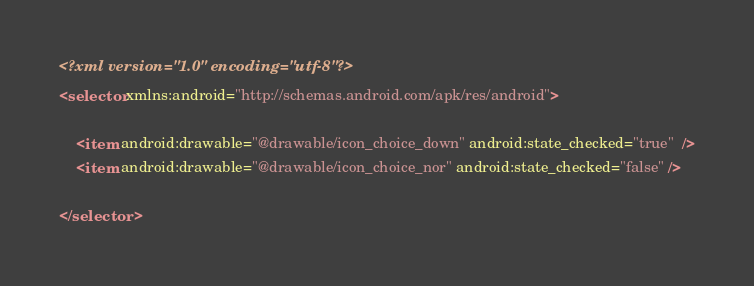Convert code to text. <code><loc_0><loc_0><loc_500><loc_500><_XML_><?xml version="1.0" encoding="utf-8"?>
<selector xmlns:android="http://schemas.android.com/apk/res/android">

    <item android:drawable="@drawable/icon_choice_down" android:state_checked="true"  />
    <item android:drawable="@drawable/icon_choice_nor" android:state_checked="false" />

</selector></code> 